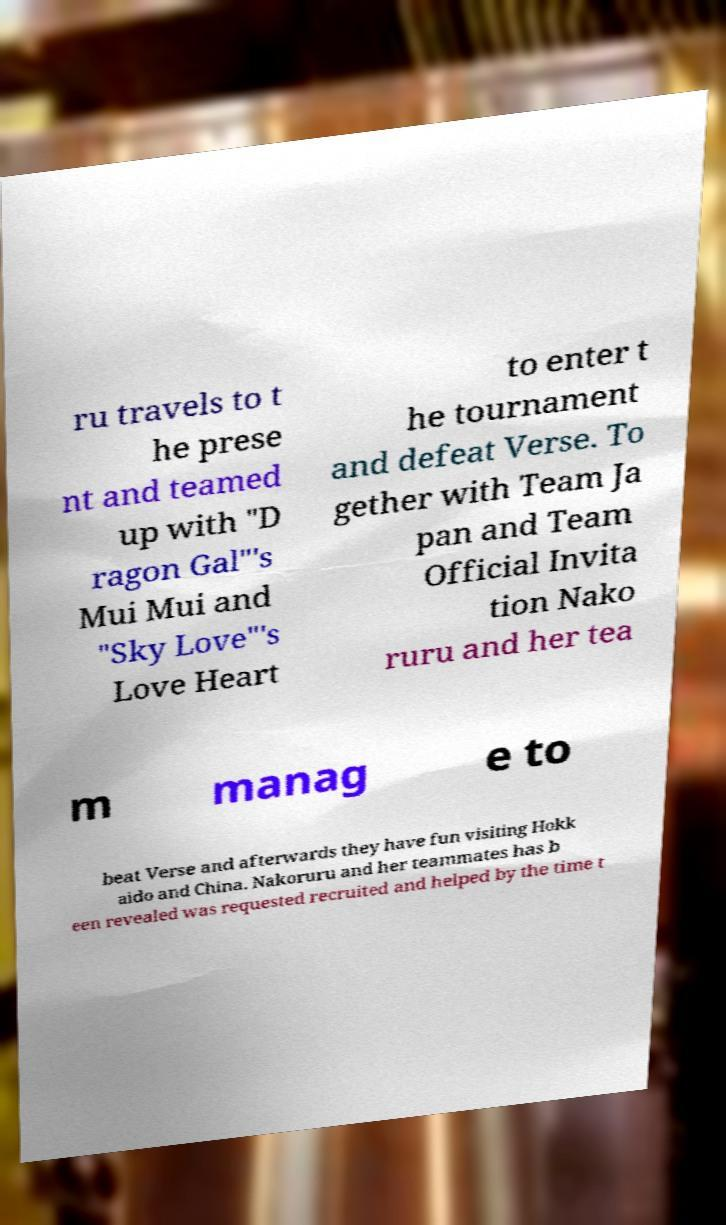Please identify and transcribe the text found in this image. ru travels to t he prese nt and teamed up with "D ragon Gal"'s Mui Mui and "Sky Love"'s Love Heart to enter t he tournament and defeat Verse. To gether with Team Ja pan and Team Official Invita tion Nako ruru and her tea m manag e to beat Verse and afterwards they have fun visiting Hokk aido and China. Nakoruru and her teammates has b een revealed was requested recruited and helped by the time t 